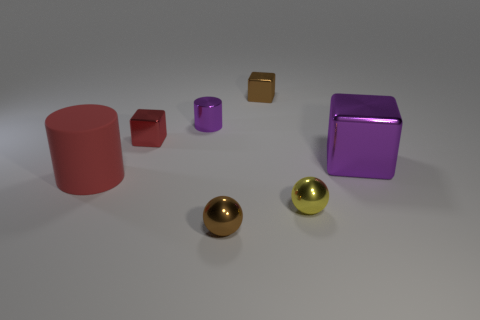Is the material of the small purple thing the same as the big red cylinder?
Provide a succinct answer. No. There is a purple metal thing that is left of the purple shiny object that is to the right of the tiny purple object; how many metallic things are behind it?
Your answer should be compact. 1. What shape is the big object left of the large shiny object?
Make the answer very short. Cylinder. How many other objects are the same material as the large red object?
Your answer should be compact. 0. Do the large metal thing and the shiny cylinder have the same color?
Ensure brevity in your answer.  Yes. Is the number of purple blocks in front of the large cylinder less than the number of brown shiny balls to the right of the small red shiny object?
Offer a terse response. Yes. What color is the large matte thing that is the same shape as the small purple metallic thing?
Provide a succinct answer. Red. Does the red object left of the red block have the same size as the large purple thing?
Your answer should be compact. Yes. Are there fewer yellow shiny spheres that are behind the large red rubber object than brown metallic objects?
Provide a succinct answer. Yes. There is a shiny ball that is to the right of the thing in front of the yellow object; what is its size?
Provide a succinct answer. Small. 